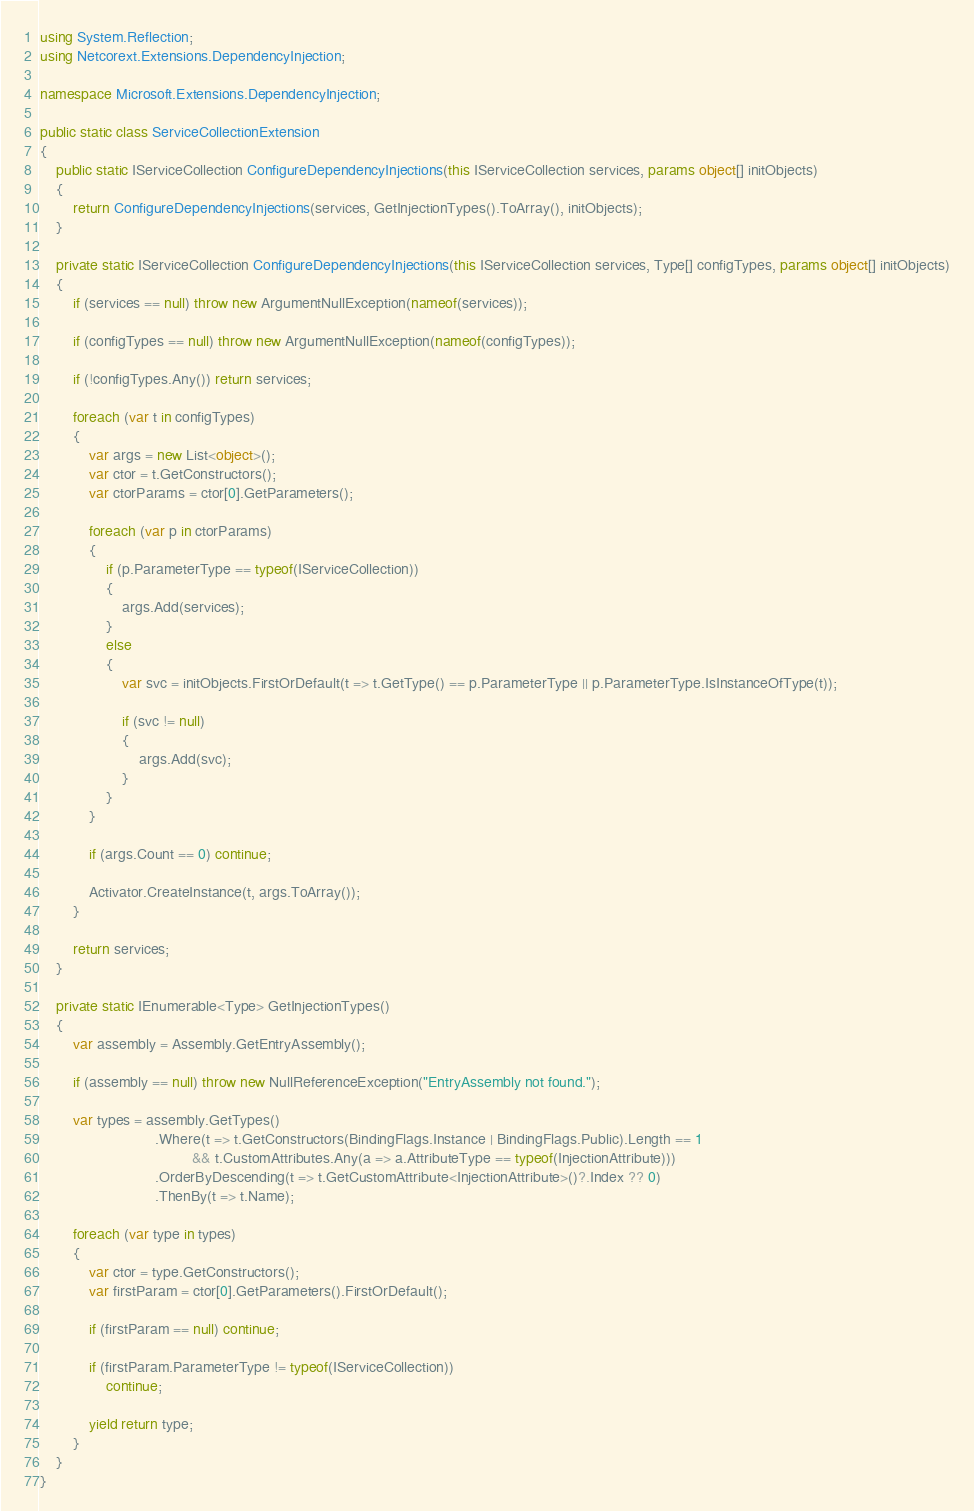<code> <loc_0><loc_0><loc_500><loc_500><_C#_>using System.Reflection;
using Netcorext.Extensions.DependencyInjection;

namespace Microsoft.Extensions.DependencyInjection;

public static class ServiceCollectionExtension
{
    public static IServiceCollection ConfigureDependencyInjections(this IServiceCollection services, params object[] initObjects)
    {
        return ConfigureDependencyInjections(services, GetInjectionTypes().ToArray(), initObjects);
    }

    private static IServiceCollection ConfigureDependencyInjections(this IServiceCollection services, Type[] configTypes, params object[] initObjects)
    {
        if (services == null) throw new ArgumentNullException(nameof(services));

        if (configTypes == null) throw new ArgumentNullException(nameof(configTypes));

        if (!configTypes.Any()) return services;

        foreach (var t in configTypes)
        {
            var args = new List<object>();
            var ctor = t.GetConstructors();
            var ctorParams = ctor[0].GetParameters();

            foreach (var p in ctorParams)
            {
                if (p.ParameterType == typeof(IServiceCollection))
                {
                    args.Add(services);
                }
                else
                {
                    var svc = initObjects.FirstOrDefault(t => t.GetType() == p.ParameterType || p.ParameterType.IsInstanceOfType(t));

                    if (svc != null)
                    {
                        args.Add(svc);
                    }
                }
            }

            if (args.Count == 0) continue;

            Activator.CreateInstance(t, args.ToArray());
        }

        return services;
    }

    private static IEnumerable<Type> GetInjectionTypes()
    {
        var assembly = Assembly.GetEntryAssembly();

        if (assembly == null) throw new NullReferenceException("EntryAssembly not found.");

        var types = assembly.GetTypes()
                            .Where(t => t.GetConstructors(BindingFlags.Instance | BindingFlags.Public).Length == 1
                                     && t.CustomAttributes.Any(a => a.AttributeType == typeof(InjectionAttribute)))
                            .OrderByDescending(t => t.GetCustomAttribute<InjectionAttribute>()?.Index ?? 0)
                            .ThenBy(t => t.Name);

        foreach (var type in types)
        {
            var ctor = type.GetConstructors();
            var firstParam = ctor[0].GetParameters().FirstOrDefault();

            if (firstParam == null) continue;

            if (firstParam.ParameterType != typeof(IServiceCollection))
                continue;

            yield return type;
        }
    }
}</code> 